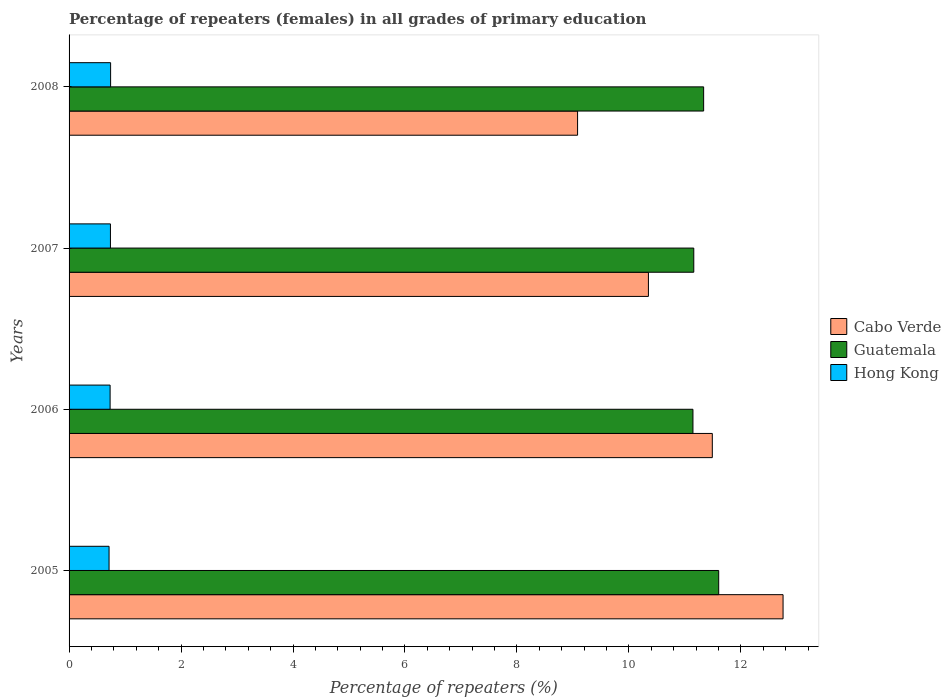How many different coloured bars are there?
Provide a short and direct response. 3. How many groups of bars are there?
Make the answer very short. 4. How many bars are there on the 3rd tick from the top?
Provide a short and direct response. 3. What is the label of the 3rd group of bars from the top?
Provide a succinct answer. 2006. What is the percentage of repeaters (females) in Hong Kong in 2008?
Offer a terse response. 0.74. Across all years, what is the maximum percentage of repeaters (females) in Hong Kong?
Make the answer very short. 0.74. Across all years, what is the minimum percentage of repeaters (females) in Guatemala?
Your response must be concise. 11.14. In which year was the percentage of repeaters (females) in Hong Kong minimum?
Give a very brief answer. 2005. What is the total percentage of repeaters (females) in Cabo Verde in the graph?
Ensure brevity in your answer.  43.67. What is the difference between the percentage of repeaters (females) in Cabo Verde in 2005 and that in 2006?
Give a very brief answer. 1.26. What is the difference between the percentage of repeaters (females) in Hong Kong in 2006 and the percentage of repeaters (females) in Cabo Verde in 2008?
Your response must be concise. -8.35. What is the average percentage of repeaters (females) in Hong Kong per year?
Make the answer very short. 0.73. In the year 2008, what is the difference between the percentage of repeaters (females) in Guatemala and percentage of repeaters (females) in Cabo Verde?
Your answer should be compact. 2.25. In how many years, is the percentage of repeaters (females) in Cabo Verde greater than 3.6 %?
Your answer should be compact. 4. What is the ratio of the percentage of repeaters (females) in Guatemala in 2007 to that in 2008?
Your response must be concise. 0.98. What is the difference between the highest and the second highest percentage of repeaters (females) in Guatemala?
Make the answer very short. 0.27. What is the difference between the highest and the lowest percentage of repeaters (females) in Hong Kong?
Your answer should be compact. 0.03. In how many years, is the percentage of repeaters (females) in Hong Kong greater than the average percentage of repeaters (females) in Hong Kong taken over all years?
Ensure brevity in your answer.  3. Is the sum of the percentage of repeaters (females) in Hong Kong in 2005 and 2007 greater than the maximum percentage of repeaters (females) in Cabo Verde across all years?
Your answer should be compact. No. What does the 3rd bar from the top in 2005 represents?
Your answer should be very brief. Cabo Verde. What does the 1st bar from the bottom in 2005 represents?
Keep it short and to the point. Cabo Verde. Is it the case that in every year, the sum of the percentage of repeaters (females) in Cabo Verde and percentage of repeaters (females) in Hong Kong is greater than the percentage of repeaters (females) in Guatemala?
Your response must be concise. No. Are all the bars in the graph horizontal?
Your response must be concise. Yes. How many years are there in the graph?
Provide a short and direct response. 4. What is the difference between two consecutive major ticks on the X-axis?
Provide a short and direct response. 2. How many legend labels are there?
Give a very brief answer. 3. How are the legend labels stacked?
Keep it short and to the point. Vertical. What is the title of the graph?
Provide a short and direct response. Percentage of repeaters (females) in all grades of primary education. What is the label or title of the X-axis?
Ensure brevity in your answer.  Percentage of repeaters (%). What is the Percentage of repeaters (%) in Cabo Verde in 2005?
Offer a terse response. 12.75. What is the Percentage of repeaters (%) in Guatemala in 2005?
Make the answer very short. 11.6. What is the Percentage of repeaters (%) in Hong Kong in 2005?
Make the answer very short. 0.71. What is the Percentage of repeaters (%) in Cabo Verde in 2006?
Provide a short and direct response. 11.49. What is the Percentage of repeaters (%) of Guatemala in 2006?
Make the answer very short. 11.14. What is the Percentage of repeaters (%) in Hong Kong in 2006?
Provide a succinct answer. 0.73. What is the Percentage of repeaters (%) in Cabo Verde in 2007?
Provide a succinct answer. 10.35. What is the Percentage of repeaters (%) in Guatemala in 2007?
Provide a succinct answer. 11.16. What is the Percentage of repeaters (%) in Hong Kong in 2007?
Your answer should be compact. 0.74. What is the Percentage of repeaters (%) in Cabo Verde in 2008?
Give a very brief answer. 9.08. What is the Percentage of repeaters (%) in Guatemala in 2008?
Give a very brief answer. 11.33. What is the Percentage of repeaters (%) in Hong Kong in 2008?
Give a very brief answer. 0.74. Across all years, what is the maximum Percentage of repeaters (%) of Cabo Verde?
Offer a terse response. 12.75. Across all years, what is the maximum Percentage of repeaters (%) in Guatemala?
Offer a terse response. 11.6. Across all years, what is the maximum Percentage of repeaters (%) in Hong Kong?
Offer a terse response. 0.74. Across all years, what is the minimum Percentage of repeaters (%) in Cabo Verde?
Your answer should be compact. 9.08. Across all years, what is the minimum Percentage of repeaters (%) in Guatemala?
Provide a short and direct response. 11.14. Across all years, what is the minimum Percentage of repeaters (%) of Hong Kong?
Keep it short and to the point. 0.71. What is the total Percentage of repeaters (%) in Cabo Verde in the graph?
Your answer should be very brief. 43.67. What is the total Percentage of repeaters (%) in Guatemala in the graph?
Offer a terse response. 45.24. What is the total Percentage of repeaters (%) in Hong Kong in the graph?
Ensure brevity in your answer.  2.93. What is the difference between the Percentage of repeaters (%) in Cabo Verde in 2005 and that in 2006?
Your response must be concise. 1.26. What is the difference between the Percentage of repeaters (%) of Guatemala in 2005 and that in 2006?
Ensure brevity in your answer.  0.46. What is the difference between the Percentage of repeaters (%) in Hong Kong in 2005 and that in 2006?
Keep it short and to the point. -0.02. What is the difference between the Percentage of repeaters (%) in Cabo Verde in 2005 and that in 2007?
Make the answer very short. 2.4. What is the difference between the Percentage of repeaters (%) in Guatemala in 2005 and that in 2007?
Provide a short and direct response. 0.45. What is the difference between the Percentage of repeaters (%) in Hong Kong in 2005 and that in 2007?
Give a very brief answer. -0.02. What is the difference between the Percentage of repeaters (%) of Cabo Verde in 2005 and that in 2008?
Offer a terse response. 3.67. What is the difference between the Percentage of repeaters (%) of Guatemala in 2005 and that in 2008?
Ensure brevity in your answer.  0.27. What is the difference between the Percentage of repeaters (%) in Hong Kong in 2005 and that in 2008?
Provide a short and direct response. -0.03. What is the difference between the Percentage of repeaters (%) of Cabo Verde in 2006 and that in 2007?
Provide a succinct answer. 1.14. What is the difference between the Percentage of repeaters (%) in Guatemala in 2006 and that in 2007?
Your response must be concise. -0.01. What is the difference between the Percentage of repeaters (%) of Hong Kong in 2006 and that in 2007?
Provide a succinct answer. -0.01. What is the difference between the Percentage of repeaters (%) in Cabo Verde in 2006 and that in 2008?
Ensure brevity in your answer.  2.41. What is the difference between the Percentage of repeaters (%) in Guatemala in 2006 and that in 2008?
Give a very brief answer. -0.19. What is the difference between the Percentage of repeaters (%) of Hong Kong in 2006 and that in 2008?
Your response must be concise. -0.01. What is the difference between the Percentage of repeaters (%) of Cabo Verde in 2007 and that in 2008?
Your response must be concise. 1.27. What is the difference between the Percentage of repeaters (%) in Guatemala in 2007 and that in 2008?
Provide a succinct answer. -0.18. What is the difference between the Percentage of repeaters (%) of Hong Kong in 2007 and that in 2008?
Your answer should be compact. -0. What is the difference between the Percentage of repeaters (%) of Cabo Verde in 2005 and the Percentage of repeaters (%) of Guatemala in 2006?
Make the answer very short. 1.61. What is the difference between the Percentage of repeaters (%) in Cabo Verde in 2005 and the Percentage of repeaters (%) in Hong Kong in 2006?
Keep it short and to the point. 12.02. What is the difference between the Percentage of repeaters (%) in Guatemala in 2005 and the Percentage of repeaters (%) in Hong Kong in 2006?
Your answer should be compact. 10.87. What is the difference between the Percentage of repeaters (%) of Cabo Verde in 2005 and the Percentage of repeaters (%) of Guatemala in 2007?
Your answer should be very brief. 1.59. What is the difference between the Percentage of repeaters (%) in Cabo Verde in 2005 and the Percentage of repeaters (%) in Hong Kong in 2007?
Your answer should be very brief. 12.01. What is the difference between the Percentage of repeaters (%) of Guatemala in 2005 and the Percentage of repeaters (%) of Hong Kong in 2007?
Offer a terse response. 10.86. What is the difference between the Percentage of repeaters (%) in Cabo Verde in 2005 and the Percentage of repeaters (%) in Guatemala in 2008?
Offer a very short reply. 1.42. What is the difference between the Percentage of repeaters (%) of Cabo Verde in 2005 and the Percentage of repeaters (%) of Hong Kong in 2008?
Ensure brevity in your answer.  12.01. What is the difference between the Percentage of repeaters (%) in Guatemala in 2005 and the Percentage of repeaters (%) in Hong Kong in 2008?
Your answer should be very brief. 10.86. What is the difference between the Percentage of repeaters (%) in Cabo Verde in 2006 and the Percentage of repeaters (%) in Guatemala in 2007?
Offer a terse response. 0.33. What is the difference between the Percentage of repeaters (%) of Cabo Verde in 2006 and the Percentage of repeaters (%) of Hong Kong in 2007?
Make the answer very short. 10.75. What is the difference between the Percentage of repeaters (%) in Guatemala in 2006 and the Percentage of repeaters (%) in Hong Kong in 2007?
Your answer should be compact. 10.4. What is the difference between the Percentage of repeaters (%) in Cabo Verde in 2006 and the Percentage of repeaters (%) in Guatemala in 2008?
Ensure brevity in your answer.  0.15. What is the difference between the Percentage of repeaters (%) in Cabo Verde in 2006 and the Percentage of repeaters (%) in Hong Kong in 2008?
Keep it short and to the point. 10.75. What is the difference between the Percentage of repeaters (%) of Guatemala in 2006 and the Percentage of repeaters (%) of Hong Kong in 2008?
Offer a terse response. 10.4. What is the difference between the Percentage of repeaters (%) in Cabo Verde in 2007 and the Percentage of repeaters (%) in Guatemala in 2008?
Your response must be concise. -0.99. What is the difference between the Percentage of repeaters (%) of Cabo Verde in 2007 and the Percentage of repeaters (%) of Hong Kong in 2008?
Your answer should be compact. 9.61. What is the difference between the Percentage of repeaters (%) in Guatemala in 2007 and the Percentage of repeaters (%) in Hong Kong in 2008?
Provide a succinct answer. 10.42. What is the average Percentage of repeaters (%) in Cabo Verde per year?
Offer a terse response. 10.92. What is the average Percentage of repeaters (%) of Guatemala per year?
Make the answer very short. 11.31. What is the average Percentage of repeaters (%) in Hong Kong per year?
Your answer should be very brief. 0.73. In the year 2005, what is the difference between the Percentage of repeaters (%) of Cabo Verde and Percentage of repeaters (%) of Guatemala?
Your answer should be very brief. 1.15. In the year 2005, what is the difference between the Percentage of repeaters (%) in Cabo Verde and Percentage of repeaters (%) in Hong Kong?
Ensure brevity in your answer.  12.04. In the year 2005, what is the difference between the Percentage of repeaters (%) in Guatemala and Percentage of repeaters (%) in Hong Kong?
Your answer should be compact. 10.89. In the year 2006, what is the difference between the Percentage of repeaters (%) of Cabo Verde and Percentage of repeaters (%) of Guatemala?
Provide a succinct answer. 0.35. In the year 2006, what is the difference between the Percentage of repeaters (%) in Cabo Verde and Percentage of repeaters (%) in Hong Kong?
Make the answer very short. 10.76. In the year 2006, what is the difference between the Percentage of repeaters (%) in Guatemala and Percentage of repeaters (%) in Hong Kong?
Your response must be concise. 10.41. In the year 2007, what is the difference between the Percentage of repeaters (%) in Cabo Verde and Percentage of repeaters (%) in Guatemala?
Provide a short and direct response. -0.81. In the year 2007, what is the difference between the Percentage of repeaters (%) of Cabo Verde and Percentage of repeaters (%) of Hong Kong?
Keep it short and to the point. 9.61. In the year 2007, what is the difference between the Percentage of repeaters (%) in Guatemala and Percentage of repeaters (%) in Hong Kong?
Offer a very short reply. 10.42. In the year 2008, what is the difference between the Percentage of repeaters (%) in Cabo Verde and Percentage of repeaters (%) in Guatemala?
Offer a terse response. -2.25. In the year 2008, what is the difference between the Percentage of repeaters (%) of Cabo Verde and Percentage of repeaters (%) of Hong Kong?
Ensure brevity in your answer.  8.34. In the year 2008, what is the difference between the Percentage of repeaters (%) of Guatemala and Percentage of repeaters (%) of Hong Kong?
Offer a terse response. 10.59. What is the ratio of the Percentage of repeaters (%) of Cabo Verde in 2005 to that in 2006?
Keep it short and to the point. 1.11. What is the ratio of the Percentage of repeaters (%) in Guatemala in 2005 to that in 2006?
Your answer should be very brief. 1.04. What is the ratio of the Percentage of repeaters (%) of Hong Kong in 2005 to that in 2006?
Ensure brevity in your answer.  0.97. What is the ratio of the Percentage of repeaters (%) of Cabo Verde in 2005 to that in 2007?
Ensure brevity in your answer.  1.23. What is the ratio of the Percentage of repeaters (%) of Guatemala in 2005 to that in 2007?
Make the answer very short. 1.04. What is the ratio of the Percentage of repeaters (%) of Hong Kong in 2005 to that in 2007?
Make the answer very short. 0.97. What is the ratio of the Percentage of repeaters (%) in Cabo Verde in 2005 to that in 2008?
Offer a terse response. 1.4. What is the ratio of the Percentage of repeaters (%) in Guatemala in 2005 to that in 2008?
Offer a very short reply. 1.02. What is the ratio of the Percentage of repeaters (%) of Hong Kong in 2005 to that in 2008?
Ensure brevity in your answer.  0.96. What is the ratio of the Percentage of repeaters (%) in Cabo Verde in 2006 to that in 2007?
Provide a short and direct response. 1.11. What is the ratio of the Percentage of repeaters (%) of Cabo Verde in 2006 to that in 2008?
Give a very brief answer. 1.26. What is the ratio of the Percentage of repeaters (%) in Guatemala in 2006 to that in 2008?
Your answer should be compact. 0.98. What is the ratio of the Percentage of repeaters (%) in Hong Kong in 2006 to that in 2008?
Offer a terse response. 0.99. What is the ratio of the Percentage of repeaters (%) in Cabo Verde in 2007 to that in 2008?
Your response must be concise. 1.14. What is the ratio of the Percentage of repeaters (%) in Guatemala in 2007 to that in 2008?
Your answer should be very brief. 0.98. What is the ratio of the Percentage of repeaters (%) in Hong Kong in 2007 to that in 2008?
Provide a short and direct response. 1. What is the difference between the highest and the second highest Percentage of repeaters (%) in Cabo Verde?
Give a very brief answer. 1.26. What is the difference between the highest and the second highest Percentage of repeaters (%) of Guatemala?
Provide a succinct answer. 0.27. What is the difference between the highest and the second highest Percentage of repeaters (%) of Hong Kong?
Keep it short and to the point. 0. What is the difference between the highest and the lowest Percentage of repeaters (%) of Cabo Verde?
Your answer should be compact. 3.67. What is the difference between the highest and the lowest Percentage of repeaters (%) of Guatemala?
Your answer should be very brief. 0.46. What is the difference between the highest and the lowest Percentage of repeaters (%) of Hong Kong?
Your answer should be compact. 0.03. 